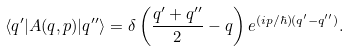Convert formula to latex. <formula><loc_0><loc_0><loc_500><loc_500>\langle q ^ { \prime } | A ( q , p ) | q ^ { \prime \prime } \rangle = \delta \left ( \frac { q ^ { \prime } + q ^ { \prime \prime } } { 2 } - q \right ) e ^ { ( i p / \hbar { ) } ( q ^ { \prime } - q ^ { \prime \prime } ) } .</formula> 